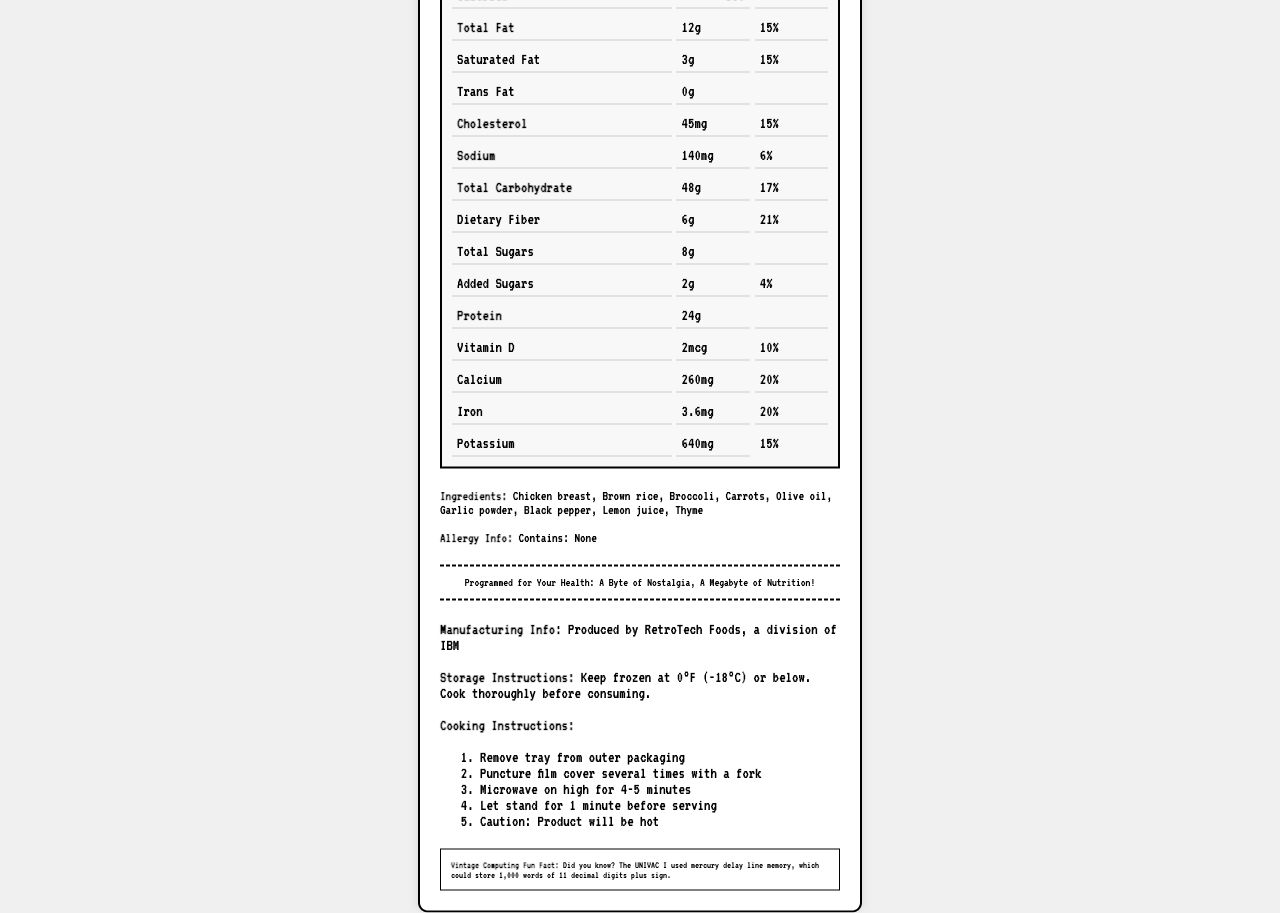what is the serving size of the UNIVAC-1 Low-Sodium Dinner? The serving size is listed at the beginning of the nutritional information as 1 tray, weighing 340 grams.
Answer: 1 tray (340g) how many calories are in one serving? The document clearly states that there are 380 calories in one serving.
Answer: 380 what is the total fat amount in the UNIVAC-1 Low-Sodium Dinner? The total fat amount is listed as 12g in the nutrition facts grid.
Answer: 12g what are the instructions for cooking this frozen dinner in a microwave? These instructions are listed under the Cooking Instructions section in the document.
Answer: Remove tray from outer packaging, Puncture film cover several times with a fork, Microwave on high for 4-5 minutes, Let stand for 1 minute before serving, Caution: Product will be hot does this product contain any allergens? The Allergy Info section states "Contains: None", indicating there are no allergens in the product.
Answer: No how much protein is in the UNIVAC-1 Low-Sodium Dinner A. 15g B. 24g C. 30g The nutrition facts grid indicates that there is 24g of protein in the dinner.
Answer: B which of the following is NOT listed as an ingredient in the UNIVAC-1 Low-Sodium Dinner? I. Broccoli II. Carrots III. Peas The Ingredients section lists "Chicken breast, Brown rice, Broccoli, Carrots, Olive oil, Garlic powder, Black pepper, Lemon juice, Thyme", but not peas.
Answer: III is the product high in sodium? The sodium content is listed as 140mg, which is 6% of the daily value, indicating it is relatively low in sodium.
Answer: No describe the main idea of this nutrition facts document. The main idea focuses on the nutritional composition, preparation, and unique design features paying homage to vintage computing systems.
Answer: This document provides detailed nutritional information about the UNIVAC-1 Low-Sodium Dinner, listing contents such as calories, fats, cholesterol, and vitamins. It includes serving size, cooking instructions, ingredient list, and a nostalgic tagline, among other details. The layout and design elements are inspired by UNIVAC punch cards. who is the target audience for this product? The document does not provide enough specific information to determine the exact target audience for the product.
Answer: Cannot be determined how much fiber does one tray of the UNIVAC-1 Low-Sodium Dinner contain? The nutrition facts grid lists the dietary fiber content as 6g.
Answer: 6g what company produced the UNIVAC-1 Low-Sodium Dinner? The Manufacturing Info section specifies that RetroTech Foods, a division of IBM, produced the product.
Answer: RetroTech Foods, a division of IBM what is unique about the layout of this nutrition facts document? The Punch Card Inspired Elements section lists these unique design features.
Answer: It mimics UNIVAC punch cards, has perforated edges, uses a monospace font reminiscent of early computer printouts, and includes a binary code border. 